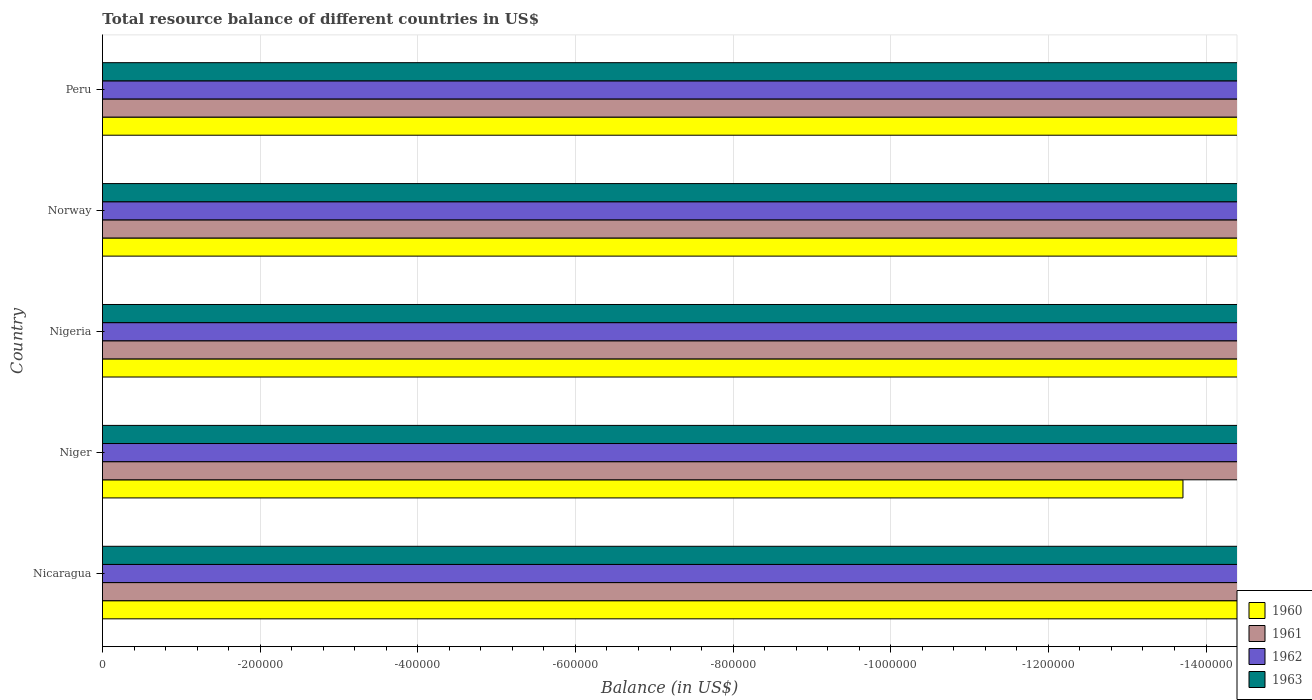Are the number of bars on each tick of the Y-axis equal?
Ensure brevity in your answer.  Yes. How many bars are there on the 1st tick from the top?
Your answer should be compact. 0. How many bars are there on the 4th tick from the bottom?
Keep it short and to the point. 0. What is the label of the 3rd group of bars from the top?
Your answer should be compact. Nigeria. Across all countries, what is the minimum total resource balance in 1962?
Your response must be concise. 0. What is the total total resource balance in 1961 in the graph?
Your answer should be compact. 0. What is the average total resource balance in 1962 per country?
Make the answer very short. 0. Is it the case that in every country, the sum of the total resource balance in 1962 and total resource balance in 1960 is greater than the sum of total resource balance in 1963 and total resource balance in 1961?
Your response must be concise. No. Are all the bars in the graph horizontal?
Offer a terse response. Yes. What is the difference between two consecutive major ticks on the X-axis?
Keep it short and to the point. 2.00e+05. Are the values on the major ticks of X-axis written in scientific E-notation?
Provide a short and direct response. No. Does the graph contain any zero values?
Keep it short and to the point. Yes. Does the graph contain grids?
Keep it short and to the point. Yes. How are the legend labels stacked?
Keep it short and to the point. Vertical. What is the title of the graph?
Make the answer very short. Total resource balance of different countries in US$. What is the label or title of the X-axis?
Your response must be concise. Balance (in US$). What is the Balance (in US$) of 1960 in Nicaragua?
Make the answer very short. 0. What is the Balance (in US$) of 1961 in Nicaragua?
Make the answer very short. 0. What is the Balance (in US$) of 1961 in Niger?
Offer a very short reply. 0. What is the Balance (in US$) of 1962 in Niger?
Keep it short and to the point. 0. What is the Balance (in US$) in 1963 in Nigeria?
Your response must be concise. 0. What is the Balance (in US$) of 1960 in Norway?
Provide a succinct answer. 0. What is the Balance (in US$) of 1961 in Norway?
Your answer should be very brief. 0. What is the Balance (in US$) of 1962 in Norway?
Give a very brief answer. 0. What is the Balance (in US$) of 1963 in Norway?
Provide a succinct answer. 0. What is the Balance (in US$) in 1961 in Peru?
Give a very brief answer. 0. What is the Balance (in US$) in 1963 in Peru?
Your response must be concise. 0. What is the total Balance (in US$) of 1960 in the graph?
Ensure brevity in your answer.  0. What is the total Balance (in US$) of 1961 in the graph?
Provide a short and direct response. 0. What is the total Balance (in US$) of 1962 in the graph?
Keep it short and to the point. 0. What is the total Balance (in US$) in 1963 in the graph?
Keep it short and to the point. 0. What is the average Balance (in US$) in 1960 per country?
Provide a succinct answer. 0. 